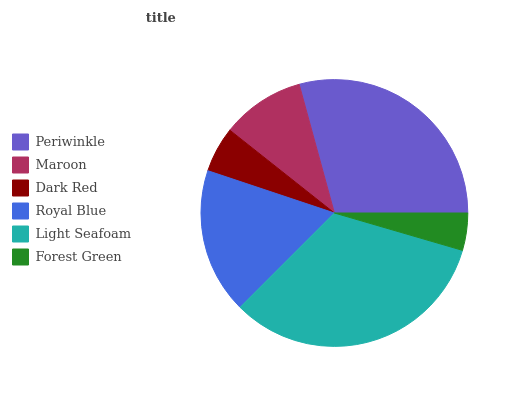Is Forest Green the minimum?
Answer yes or no. Yes. Is Light Seafoam the maximum?
Answer yes or no. Yes. Is Maroon the minimum?
Answer yes or no. No. Is Maroon the maximum?
Answer yes or no. No. Is Periwinkle greater than Maroon?
Answer yes or no. Yes. Is Maroon less than Periwinkle?
Answer yes or no. Yes. Is Maroon greater than Periwinkle?
Answer yes or no. No. Is Periwinkle less than Maroon?
Answer yes or no. No. Is Royal Blue the high median?
Answer yes or no. Yes. Is Maroon the low median?
Answer yes or no. Yes. Is Maroon the high median?
Answer yes or no. No. Is Light Seafoam the low median?
Answer yes or no. No. 